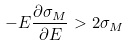<formula> <loc_0><loc_0><loc_500><loc_500>- E \frac { \partial \sigma _ { M } } { \partial E } > 2 \sigma _ { M }</formula> 